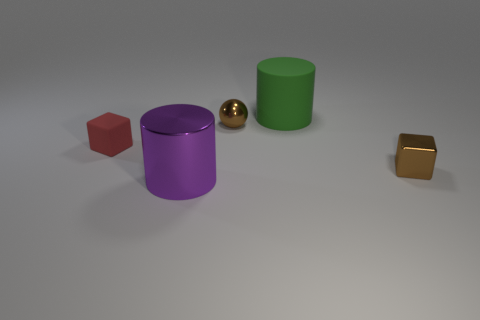Subtract all yellow spheres. Subtract all gray cylinders. How many spheres are left? 1 Add 2 rubber spheres. How many objects exist? 7 Subtract all spheres. How many objects are left? 4 Add 2 brown things. How many brown things are left? 4 Add 5 big yellow matte objects. How many big yellow matte objects exist? 5 Subtract 0 blue blocks. How many objects are left? 5 Subtract all red things. Subtract all small brown things. How many objects are left? 2 